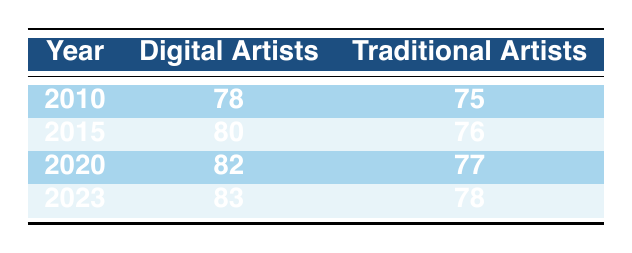What was the life expectancy of digital artists in 2020? The table shows that the life expectancy of digital artists in 2020 is 82 years, as indicated in the appropriate row for that year.
Answer: 82 What is the life expectancy of traditional artists in 2015? Referring to the table, the life expectancy of traditional artists in 2015 is 76 years, as seen in the relevant row for that year.
Answer: 76 Which group had a higher life expectancy in 2010? In 2010, the life expectancy for digital artists was 78 years, while traditional artists had a life expectancy of 75 years, showing that digital artists had a higher life expectancy.
Answer: Digital artists What is the average life expectancy of digital artists from 2010 to 2023? The life expectancy values for digital artists from 2010 to 2023 are 78, 80, 82, and 83. Adding these gives a total of 323, and dividing by 4 (the number of years) results in an average of 80.75.
Answer: 80.75 Did the life expectancy of traditional artists increase from 2010 to 2023? By comparing the values in the table, traditional artists' life expectancy increased from 75 years in 2010 to 78 years in 2023, indicating an increase over that period.
Answer: Yes What was the percentage increase in life expectancy for digital artists from 2015 to 2023? Digital artists had a life expectancy of 80 years in 2015 and 83 years in 2023. The increase is 3 years (83 - 80 = 3). The percentage increase is calculated as (3/80) * 100, which equals 3.75%.
Answer: 3.75% How much longer did digital artists live than traditional artists in 2020? In 2020, digital artists had a life expectancy of 82 years, and traditional artists had 77 years. The difference is 82 - 77 = 5 years, showing that digital artists lived 5 years longer than traditional artists in that year.
Answer: 5 years In which year did traditional artists have the lowest life expectancy? By analyzing the data, the lowest life expectancy for traditional artists was in 2010 when it was 75 years, as found in the corresponding row of the table.
Answer: 2010 What was the overall trend in life expectancy for digital artists from 2010 to 2023? Looking at the table, the life expectancy for digital artists increased each year from 78 in 2010 to 83 in 2023, demonstrating a consistent upward trend over the years.
Answer: Increasing trend 